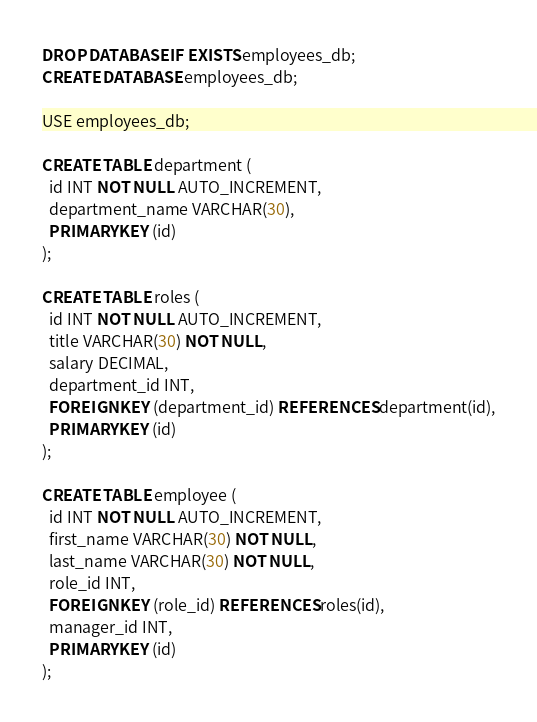<code> <loc_0><loc_0><loc_500><loc_500><_SQL_>DROP DATABASE IF EXISTS employees_db;
CREATE DATABASE employees_db;

USE employees_db;

CREATE TABLE department (
  id INT NOT NULL AUTO_INCREMENT,
  department_name VARCHAR(30),
  PRIMARY KEY (id)
);

CREATE TABLE roles (
  id INT NOT NULL AUTO_INCREMENT,
  title VARCHAR(30) NOT NULL,
  salary DECIMAL,
  department_id INT,
  FOREIGN KEY (department_id) REFERENCES department(id),
  PRIMARY KEY (id)
);

CREATE TABLE employee (
  id INT NOT NULL AUTO_INCREMENT,
  first_name VARCHAR(30) NOT NULL,
  last_name VARCHAR(30) NOT NULL,
  role_id INT,
  FOREIGN KEY (role_id) REFERENCES roles(id),
  manager_id INT,
  PRIMARY KEY (id)
);

</code> 